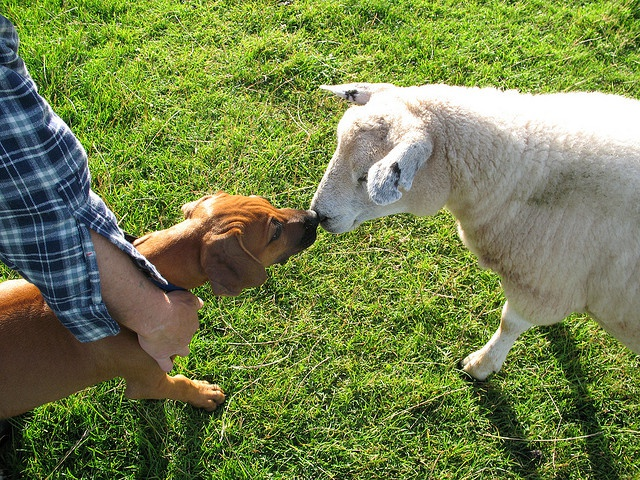Describe the objects in this image and their specific colors. I can see sheep in green, darkgray, white, and gray tones, people in green, gray, black, blue, and navy tones, and dog in green, maroon, black, and orange tones in this image. 